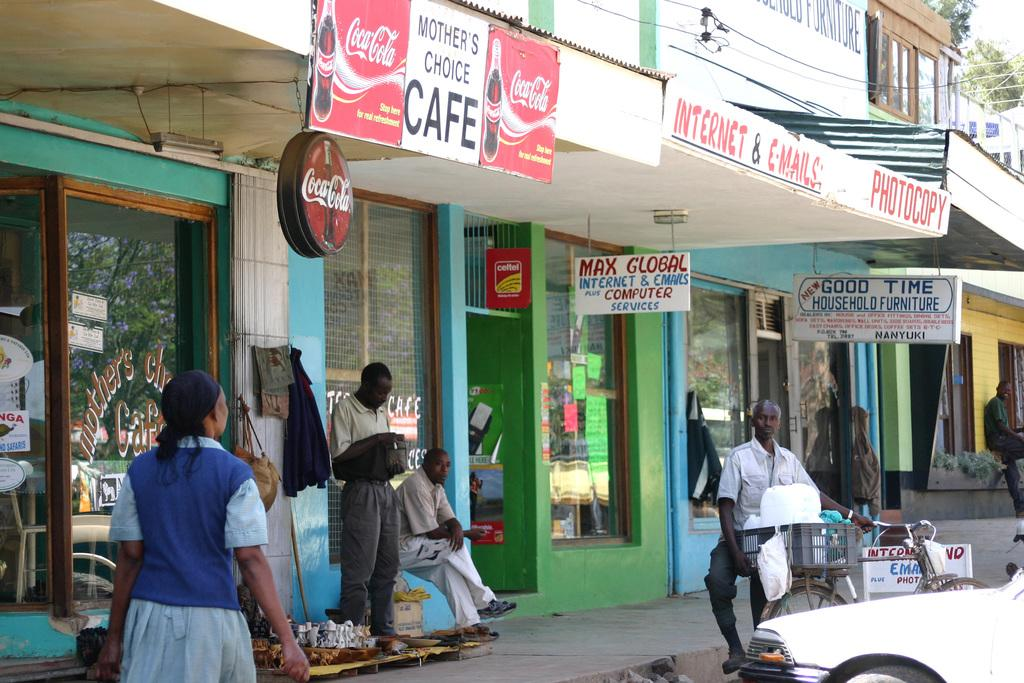<image>
Provide a brief description of the given image. Mother's Choice Cafe with a Coca Cola sign, Also another store with Max Global Internet and Games with Computer Accessories. 